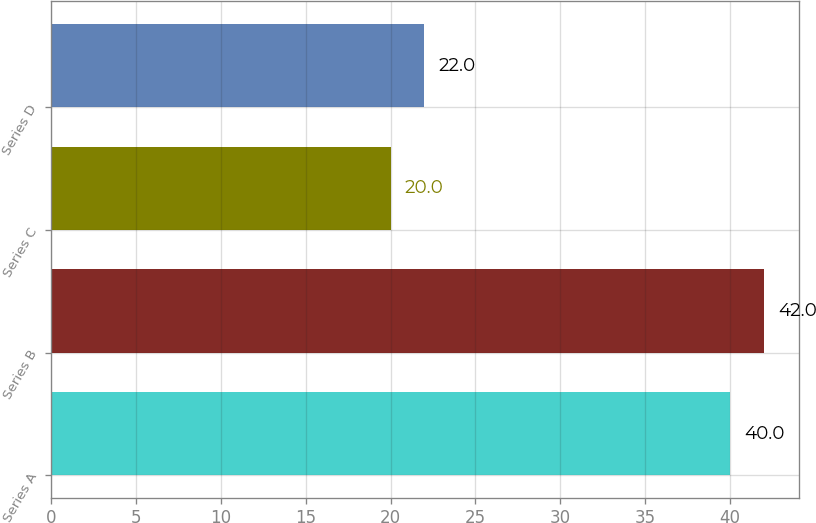Convert chart. <chart><loc_0><loc_0><loc_500><loc_500><bar_chart><fcel>Series A<fcel>Series B<fcel>Series C<fcel>Series D<nl><fcel>40<fcel>42<fcel>20<fcel>22<nl></chart> 